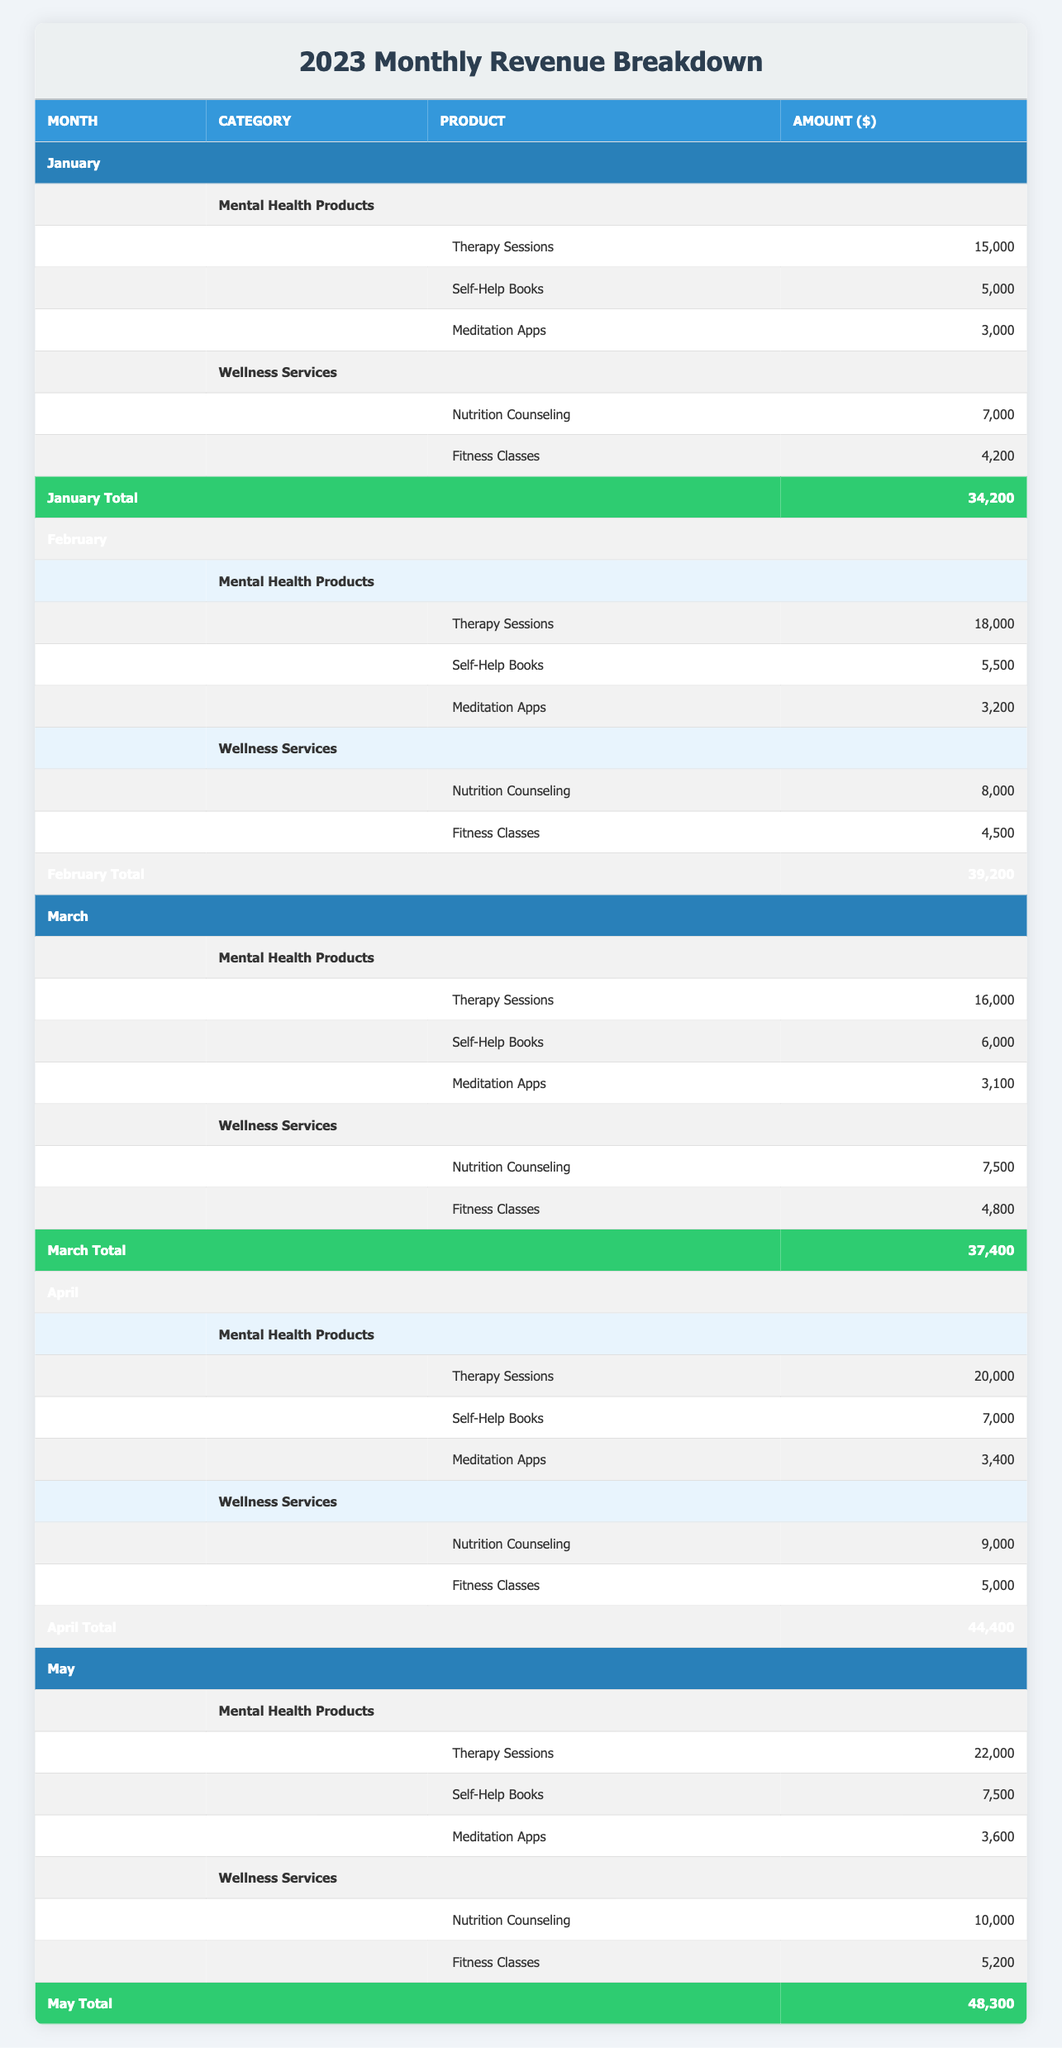What is the total revenue for January? The total revenue for January can be calculated by adding the revenues from all product categories listed. The amounts are 15,000 (Therapy Sessions) + 5,000 (Self-Help Books) + 3,000 (Meditation Apps) + 7,000 (Nutrition Counseling) + 4,200 (Fitness Classes). Summing these gives us a total of 34,200.
Answer: 34,200 Which product category had the highest revenue in May? In May, we need to compare the total revenue from both product categories. Mental Health Products total is 22,000 + 7,500 + 3,600 = 33,100, and Wellness Services total is 10,000 + 5,200 = 15,200. The highest revenue is from Mental Health Products at 33,100.
Answer: Mental Health Products Did the revenue from Therapy Sessions increase from January to April? To determine this, we look at the amounts for Therapy Sessions in January (15,000) and April (20,000). Since 20,000 is greater than 15,000, the revenue did increase.
Answer: Yes What was the average revenue for Wellness Services from January to May? We first find the Wellness Services revenue for each month: January (7,000) + February (8,000) + March (7,500) + April (9,000) + May (10,000). The total is 41,500, and there are 5 months. So the average is 41,500 / 5 = 8,300.
Answer: 8,300 Was there any month in which the total revenue was above 40,000? Comparing the total revues calculated for each month: January (34,200), February (39,200), March (37,400), April (44,400), and May (48,300). April (44,400) and May (48,300) are both above 40,000.
Answer: Yes In which month did Nutrition Counseling generate the highest revenue? We look at the revenue for Nutrition Counseling in each month: January (7,000), February (8,000), March (7,500), April (9,000), May (10,000). The highest revenue occurred in May at 10,000.
Answer: May How much more did self-help books earn in April compared to January? We compare the revenue for Self-Help Books in both months: April (7,000) and January (5,000). To find the difference, we subtract: 7,000 - 5,000 = 2,000.
Answer: 2,000 Which month has the highest total revenue? The total revenues for each month are: January (34,200), February (39,200), March (37,400), April (44,400), May (48,300). May has the highest total revenue at 48,300.
Answer: May 